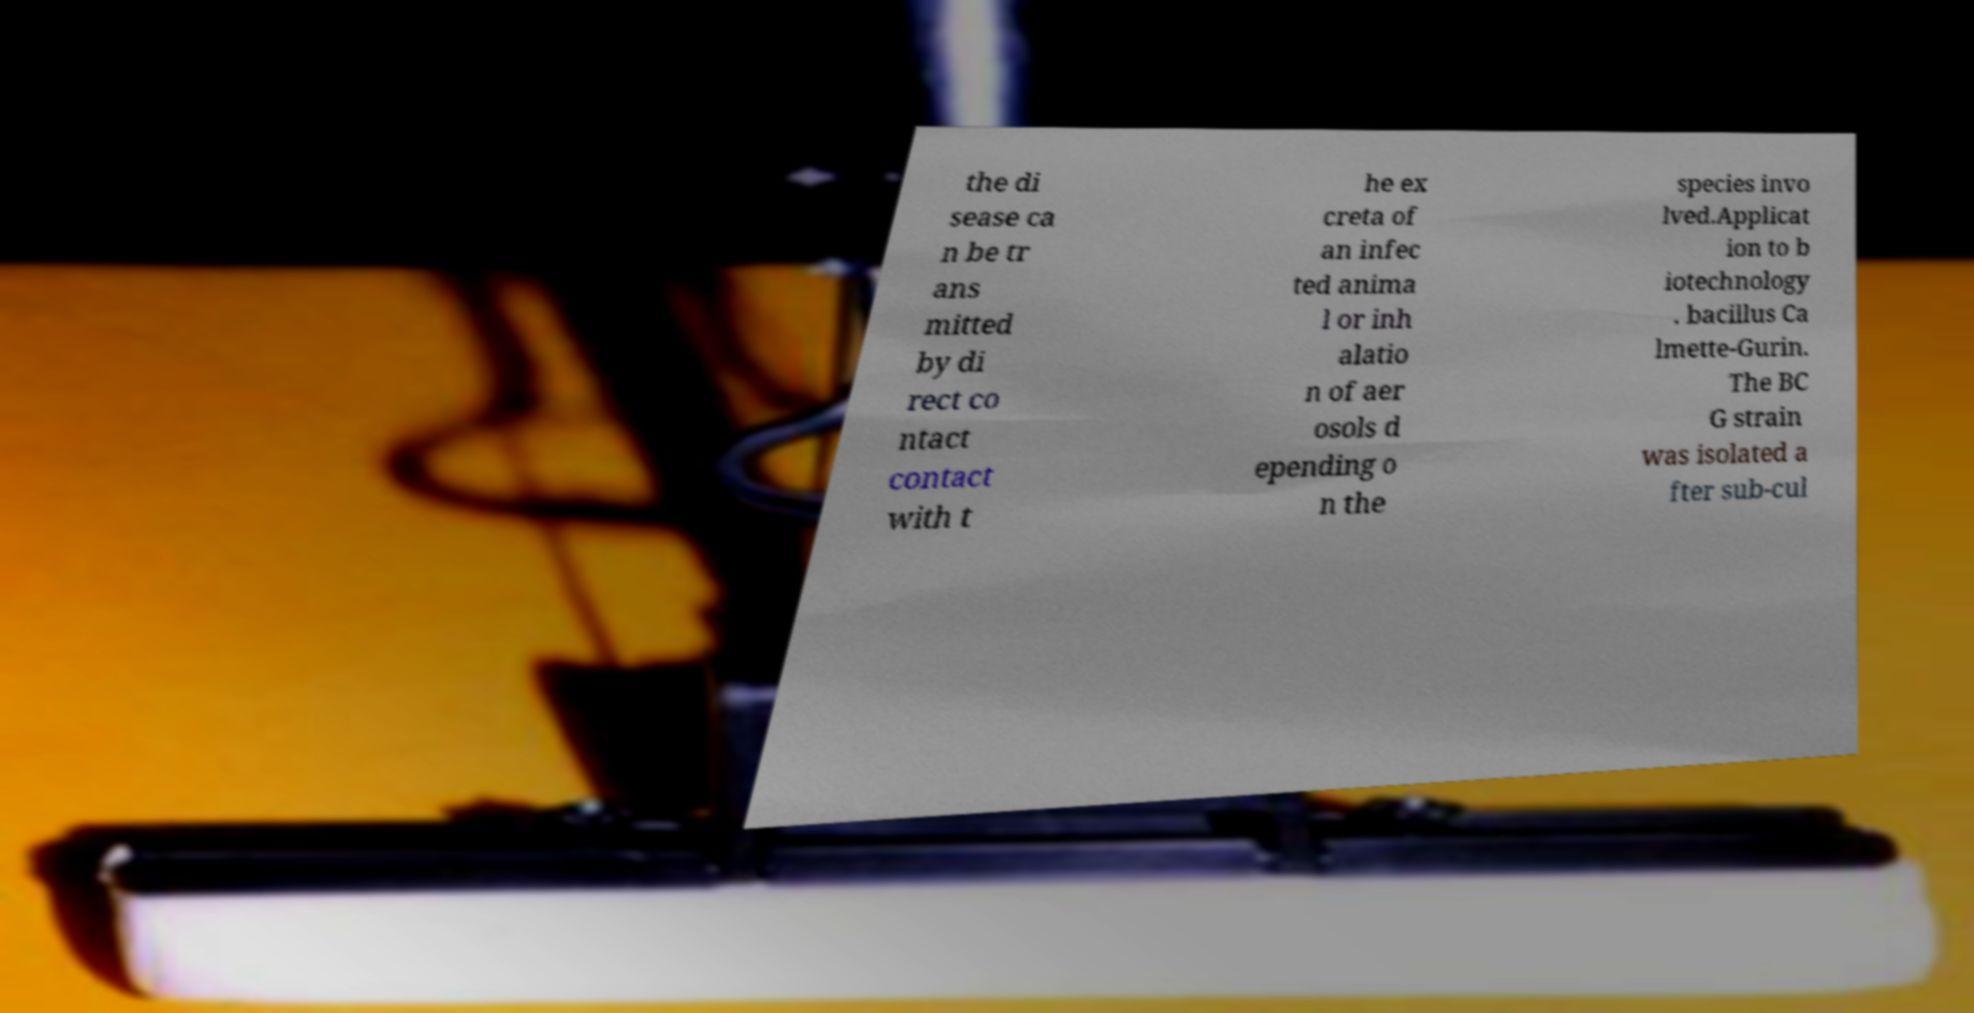Please read and relay the text visible in this image. What does it say? the di sease ca n be tr ans mitted by di rect co ntact contact with t he ex creta of an infec ted anima l or inh alatio n of aer osols d epending o n the species invo lved.Applicat ion to b iotechnology . bacillus Ca lmette-Gurin. The BC G strain was isolated a fter sub-cul 